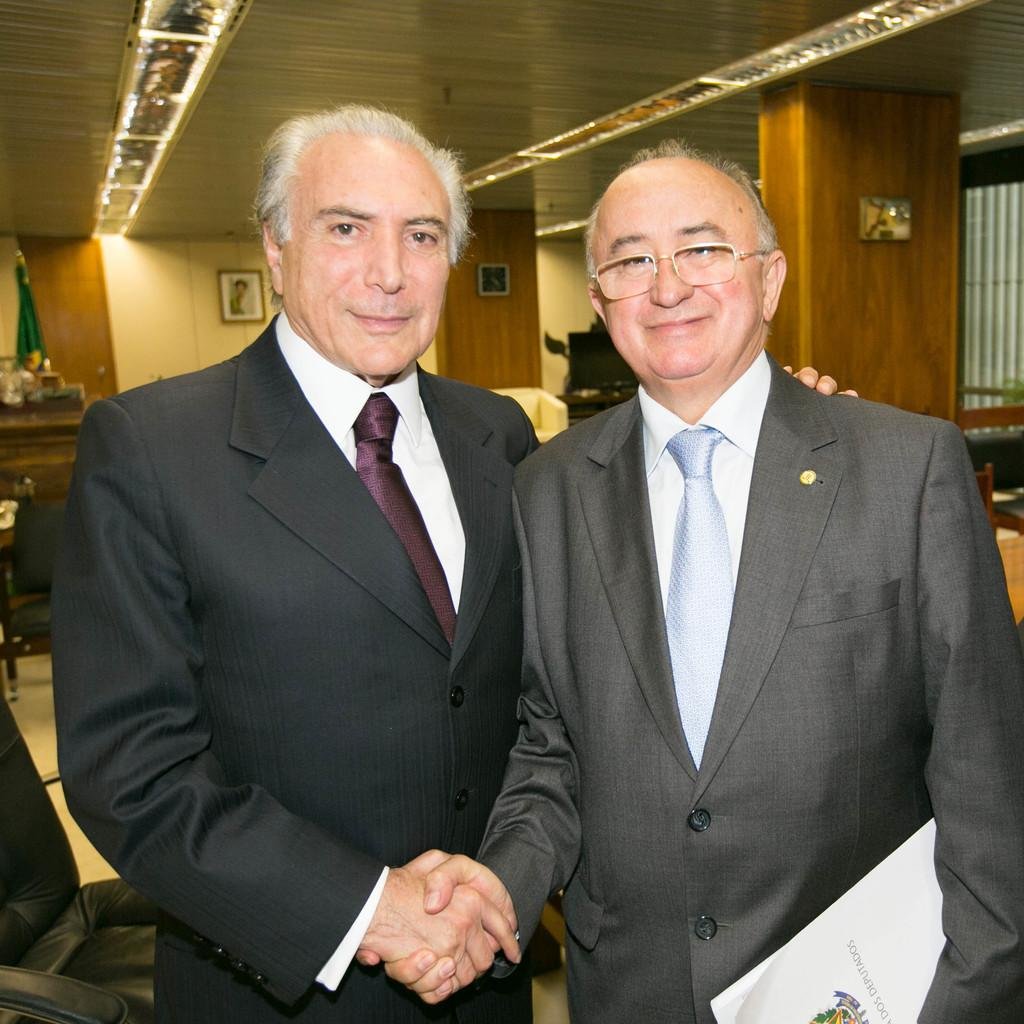How many people are in the image? There are two persons in the image. Can you describe one of the persons in the image? One person is wearing spectacles. What can be seen in the background of the image? There is a wall in the background of the image. How loud is the quiet hour in the image? There is no mention of a quiet hour or any sound levels in the image, so it cannot be determined. 